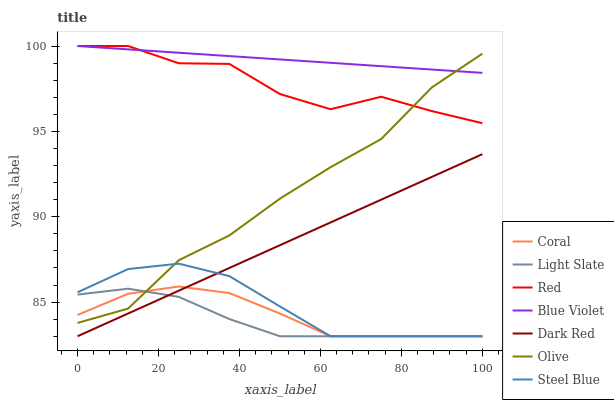Does Light Slate have the minimum area under the curve?
Answer yes or no. Yes. Does Blue Violet have the maximum area under the curve?
Answer yes or no. Yes. Does Dark Red have the minimum area under the curve?
Answer yes or no. No. Does Dark Red have the maximum area under the curve?
Answer yes or no. No. Is Blue Violet the smoothest?
Answer yes or no. Yes. Is Red the roughest?
Answer yes or no. Yes. Is Dark Red the smoothest?
Answer yes or no. No. Is Dark Red the roughest?
Answer yes or no. No. Does Red have the lowest value?
Answer yes or no. No. Does Blue Violet have the highest value?
Answer yes or no. Yes. Does Dark Red have the highest value?
Answer yes or no. No. Is Dark Red less than Blue Violet?
Answer yes or no. Yes. Is Blue Violet greater than Coral?
Answer yes or no. Yes. Does Coral intersect Dark Red?
Answer yes or no. Yes. Is Coral less than Dark Red?
Answer yes or no. No. Is Coral greater than Dark Red?
Answer yes or no. No. Does Dark Red intersect Blue Violet?
Answer yes or no. No. 